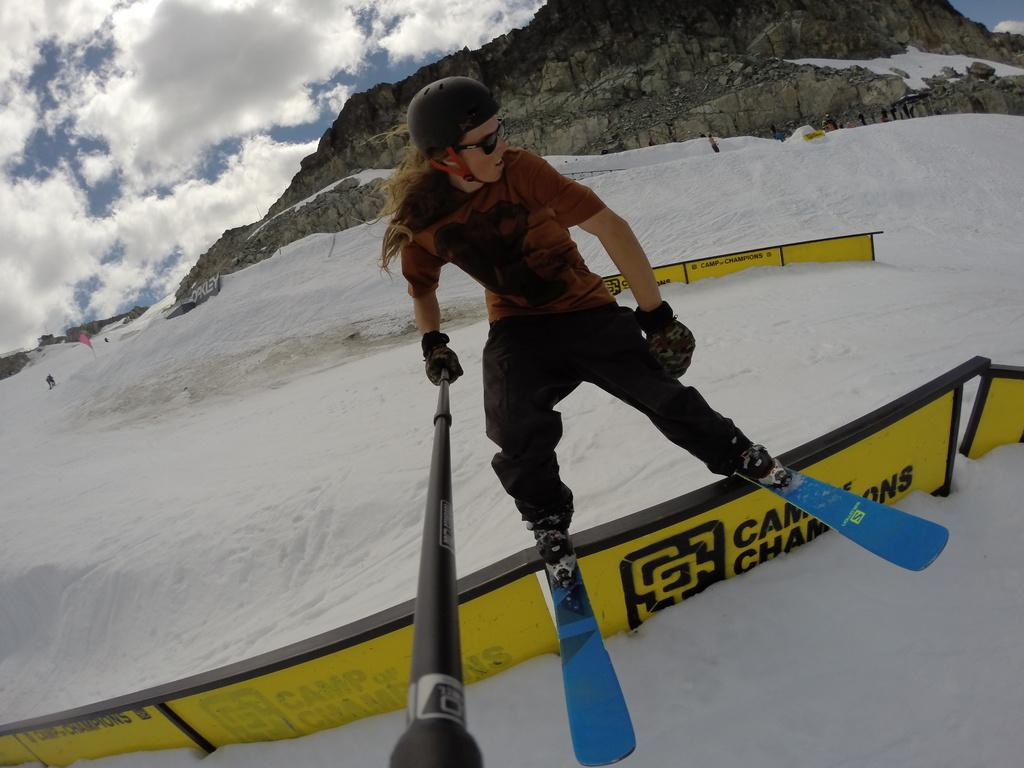What can be seen in the image? There is a person in the image, and they are holding a stick. What is the person standing near in the image? There is fencing in the image. What is the weather like in the image? There is snow in the image, and clouds are visible in the sky. What is the terrain like in the image? There are hills in the image. What part of the natural environment is visible in the image? The sky is visible in the image. What type of book is the person reading in the image? There is no book present in the image, and the person is not reading. 